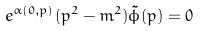<formula> <loc_0><loc_0><loc_500><loc_500>e ^ { \alpha ( 0 , p ) } ( p ^ { 2 } - m ^ { 2 } ) \tilde { \phi } ( p ) = 0</formula> 